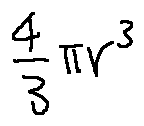<formula> <loc_0><loc_0><loc_500><loc_500>\frac { 4 } { 3 } \pi r ^ { 3 }</formula> 